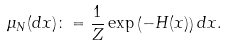Convert formula to latex. <formula><loc_0><loc_0><loc_500><loc_500>\mu _ { N } ( d x ) \colon = \frac { 1 } { Z } \exp \left ( - H ( x ) \right ) d x .</formula> 